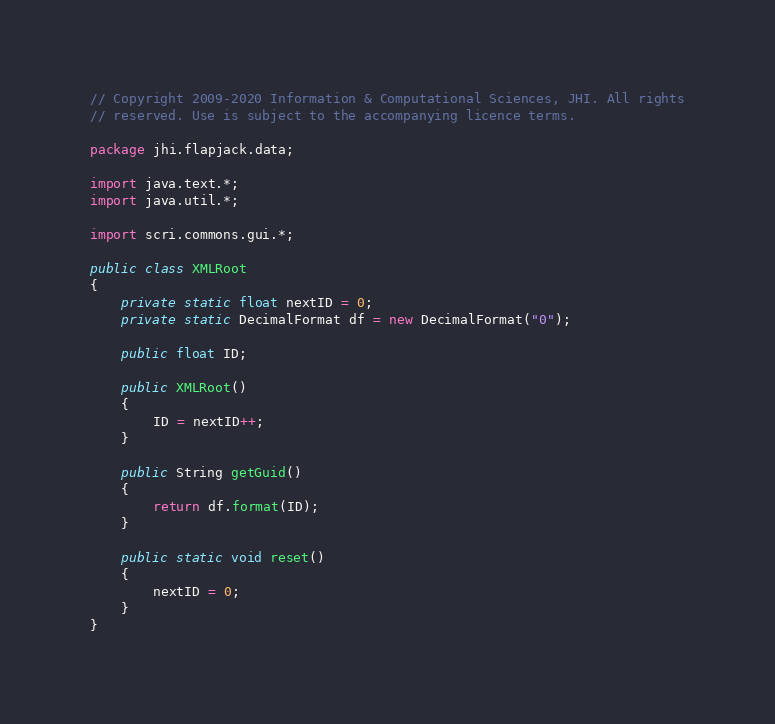Convert code to text. <code><loc_0><loc_0><loc_500><loc_500><_Java_>// Copyright 2009-2020 Information & Computational Sciences, JHI. All rights
// reserved. Use is subject to the accompanying licence terms.

package jhi.flapjack.data;

import java.text.*;
import java.util.*;

import scri.commons.gui.*;

public class XMLRoot
{
	private static float nextID = 0;
	private static DecimalFormat df = new DecimalFormat("0");

	public float ID;

	public XMLRoot()
	{
		ID = nextID++;
	}

	public String getGuid()
	{
		return df.format(ID);
	}

	public static void reset()
	{
		nextID = 0;
	}
}</code> 